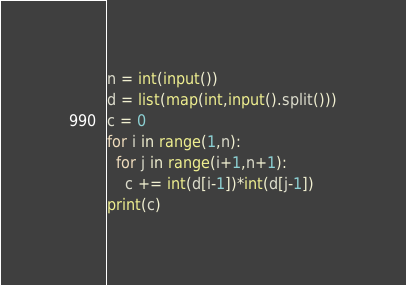<code> <loc_0><loc_0><loc_500><loc_500><_Python_>n = int(input())
d = list(map(int,input().split()))
c = 0
for i in range(1,n):
  for j in range(i+1,n+1):
    c += int(d[i-1])*int(d[j-1])
print(c)</code> 